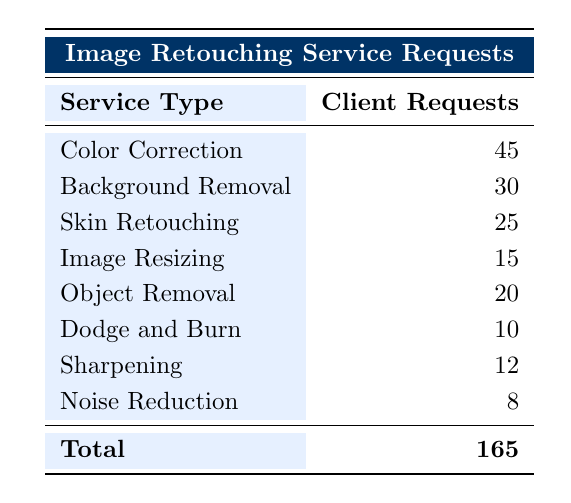What is the service type with the highest number of client requests? The table shows a breakdown of client requests by service type. The service type with the highest number is "Color Correction," with 45 requests.
Answer: Color Correction How many client requests were made for Background Removal? Looking at the table, the number of client requests for Background Removal is listed as 30.
Answer: 30 What is the total number of client requests for image retouching services? The total number of client requests is provided at the bottom of the table, which sums all the requests: 45 + 30 + 25 + 15 + 20 + 10 + 12 + 8 = 165.
Answer: 165 Which service type has fewer requests, Skin Retouching or Object Removal? Comparing the two services, Skin Retouching has 25 requests, and Object Removal has 20 requests. Since 20 is less than 25, Object Removal has fewer requests.
Answer: Object Removal What is the average number of client requests for the services listed in the table? To find the average, we sum the total client requests (165) and divide by the number of service types (8): 165 / 8 = 20.625. Thus, the average is approximately 20.625.
Answer: 20.625 Is the number of requests for Noise Reduction greater than that for Sharpening? Checking the table, Noise Reduction has 8 requests while Sharpening has 12. Since 8 is not greater than 12, the statement is false.
Answer: No What is the difference in client requests between Color Correction and Dodge and Burn? Color Correction has 45 requests, and Dodge and Burn has 10 requests. The difference is 45 - 10 = 35.
Answer: 35 If we combine the client requests for both Image Resizing and Object Removal, what is the total? Image Resizing has 15 requests and Object Removal has 20. Adding these together gives 15 + 20 = 35.
Answer: 35 How do the requests for Skin Retouching compare to those for Noise Reduction? Skin Retouching has 25 requests and Noise Reduction has 8 requests. Since 25 is greater than 8, Skin Retouching has more requests.
Answer: Yes 